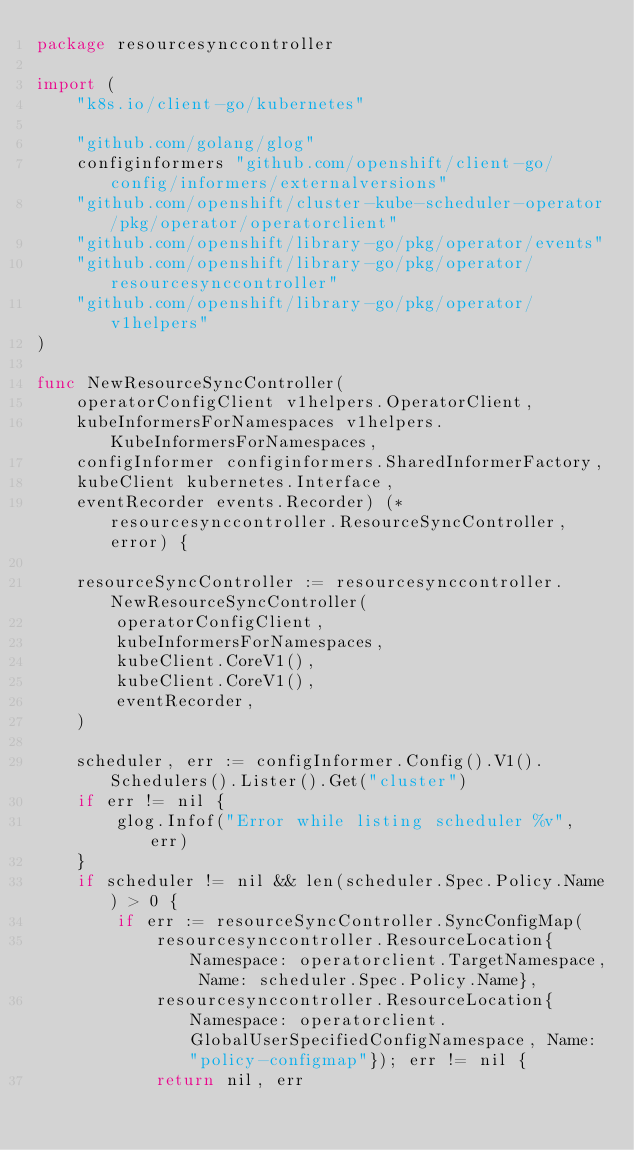Convert code to text. <code><loc_0><loc_0><loc_500><loc_500><_Go_>package resourcesynccontroller

import (
	"k8s.io/client-go/kubernetes"

	"github.com/golang/glog"
	configinformers "github.com/openshift/client-go/config/informers/externalversions"
	"github.com/openshift/cluster-kube-scheduler-operator/pkg/operator/operatorclient"
	"github.com/openshift/library-go/pkg/operator/events"
	"github.com/openshift/library-go/pkg/operator/resourcesynccontroller"
	"github.com/openshift/library-go/pkg/operator/v1helpers"
)

func NewResourceSyncController(
	operatorConfigClient v1helpers.OperatorClient,
	kubeInformersForNamespaces v1helpers.KubeInformersForNamespaces,
	configInformer configinformers.SharedInformerFactory,
	kubeClient kubernetes.Interface,
	eventRecorder events.Recorder) (*resourcesynccontroller.ResourceSyncController, error) {

	resourceSyncController := resourcesynccontroller.NewResourceSyncController(
		operatorConfigClient,
		kubeInformersForNamespaces,
		kubeClient.CoreV1(),
		kubeClient.CoreV1(),
		eventRecorder,
	)

	scheduler, err := configInformer.Config().V1().Schedulers().Lister().Get("cluster")
	if err != nil {
		glog.Infof("Error while listing scheduler %v", err)
	}
	if scheduler != nil && len(scheduler.Spec.Policy.Name) > 0 {
		if err := resourceSyncController.SyncConfigMap(
			resourcesynccontroller.ResourceLocation{Namespace: operatorclient.TargetNamespace, Name: scheduler.Spec.Policy.Name},
			resourcesynccontroller.ResourceLocation{Namespace: operatorclient.GlobalUserSpecifiedConfigNamespace, Name: "policy-configmap"}); err != nil {
			return nil, err</code> 